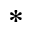<formula> <loc_0><loc_0><loc_500><loc_500>^ { * }</formula> 